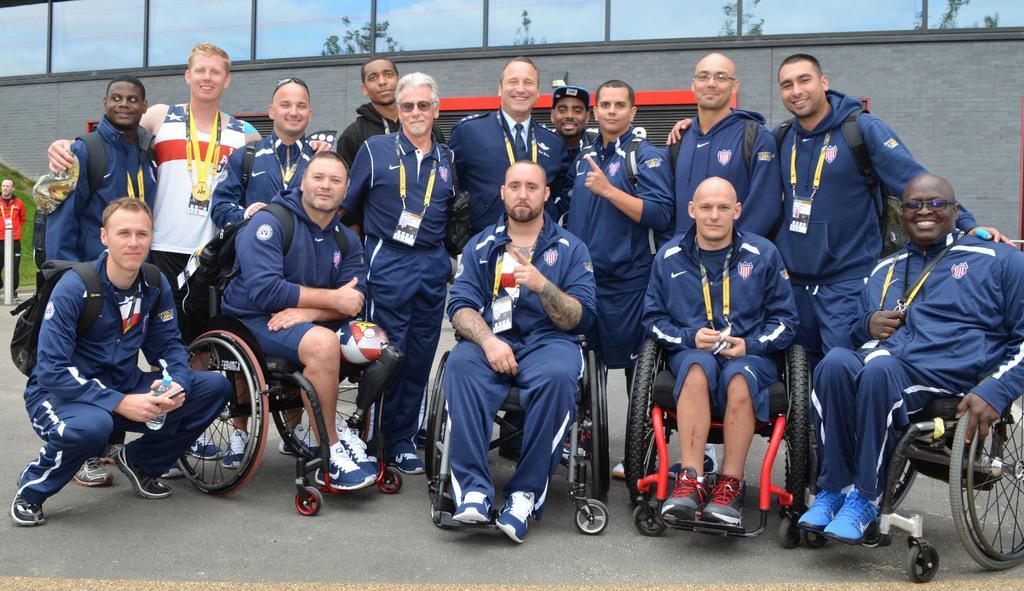How would you summarize this image in a sentence or two? In this image I can see group of people, some are sitting and some are standing and they are wearing blue color dresses. Background I can see few other persons standing, few glass windows and the building is in gray color. 